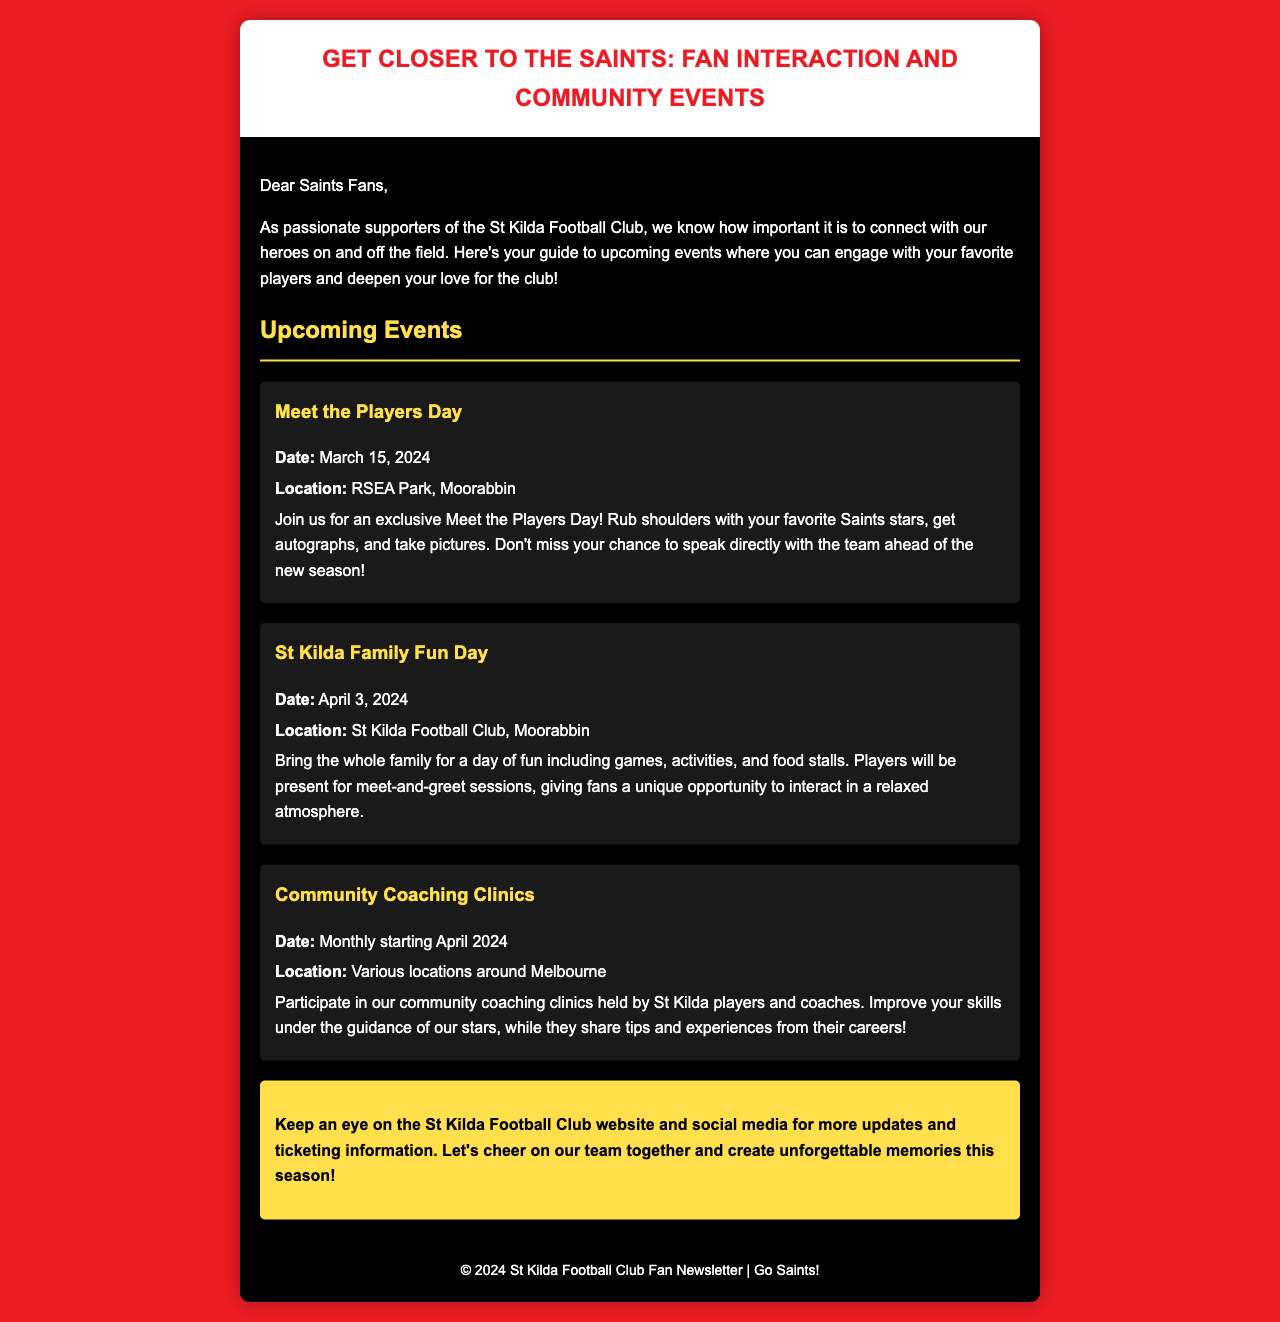What is the date of Meet the Players Day? The date is explicitly mentioned in the event details for Meet the Players Day.
Answer: March 15, 2024 Where is the St Kilda Family Fun Day being held? The location is specified in the event information for the St Kilda Family Fun Day.
Answer: St Kilda Football Club, Moorabbin What type of event is held monthly starting in April 2024? This information is derived from the details provided about community engagements in the newsletter.
Answer: Community Coaching Clinics What is included in the Meet the Players Day? The description of the Meet the Players Day event specifies activities available for fans at the event.
Answer: Autographs and pictures What color scheme is used predominantly in the newsletter? The color choices for the background, text, and headings reflect a specific color scheme throughout the document.
Answer: Red and black How can fans stay updated on events? The newsletter provides a specific suggestion on where to check for updates regarding the events mentioned.
Answer: St Kilda Football Club website and social media 